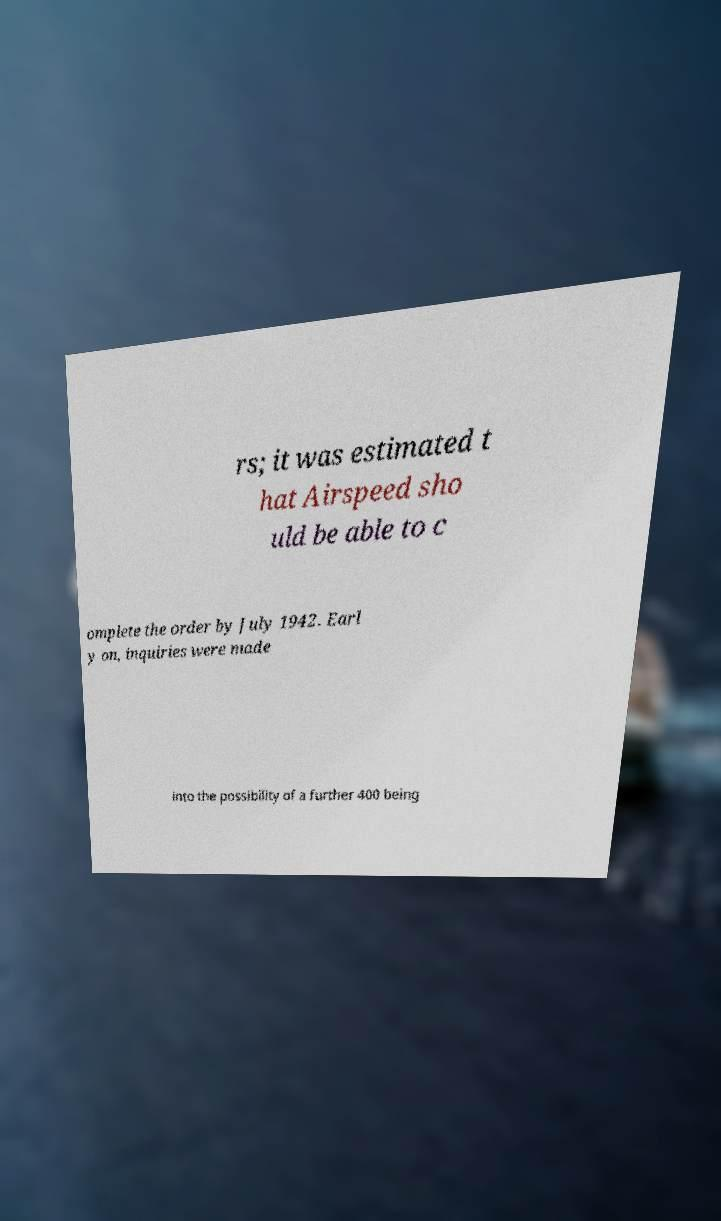Can you read and provide the text displayed in the image?This photo seems to have some interesting text. Can you extract and type it out for me? rs; it was estimated t hat Airspeed sho uld be able to c omplete the order by July 1942. Earl y on, inquiries were made into the possibility of a further 400 being 